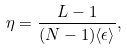Convert formula to latex. <formula><loc_0><loc_0><loc_500><loc_500>\eta = \frac { L - 1 } { ( N - 1 ) \langle \epsilon \rangle } ,</formula> 